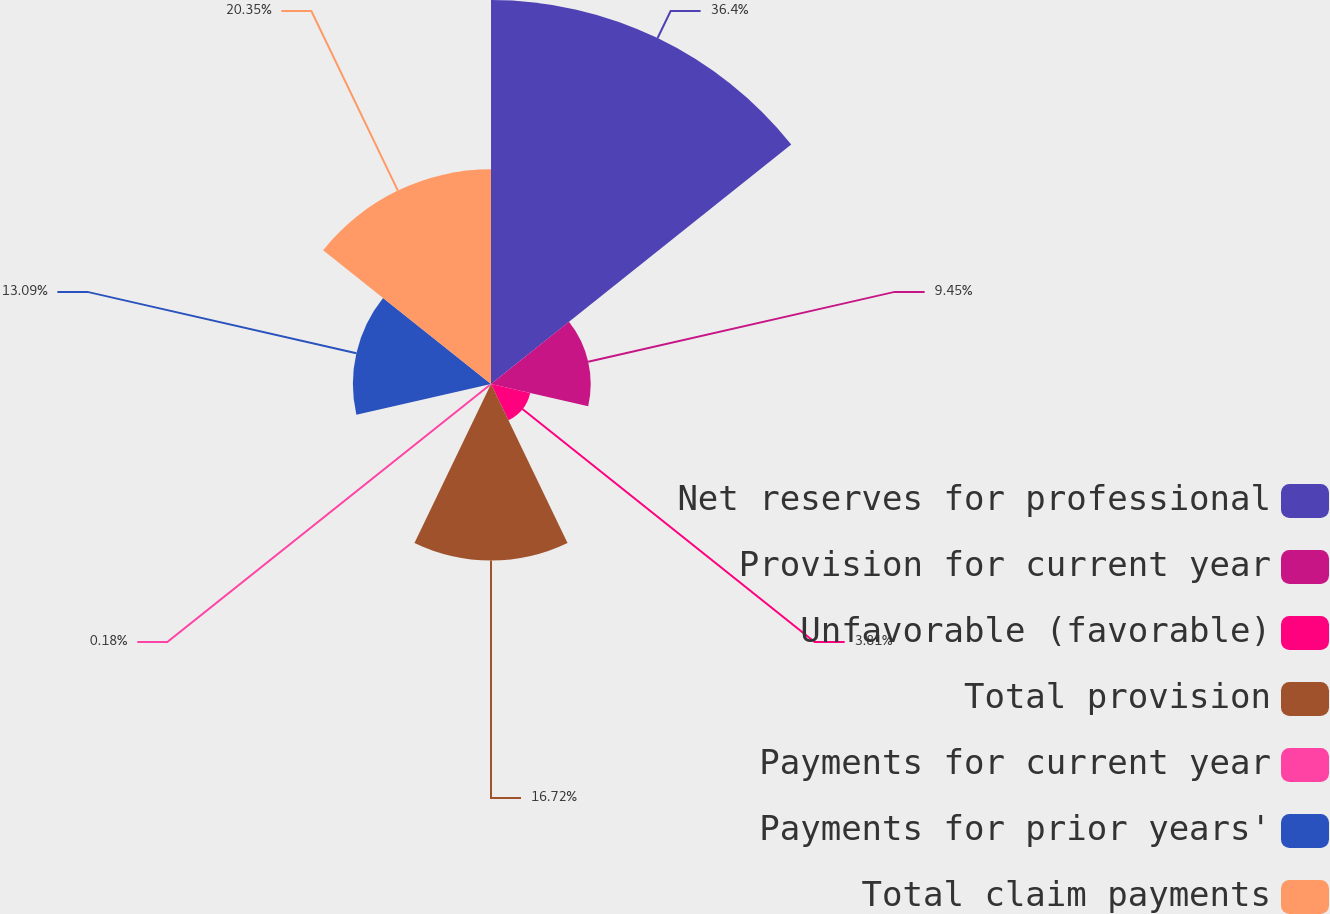Convert chart. <chart><loc_0><loc_0><loc_500><loc_500><pie_chart><fcel>Net reserves for professional<fcel>Provision for current year<fcel>Unfavorable (favorable)<fcel>Total provision<fcel>Payments for current year<fcel>Payments for prior years'<fcel>Total claim payments<nl><fcel>36.4%<fcel>9.45%<fcel>3.81%<fcel>16.72%<fcel>0.18%<fcel>13.09%<fcel>20.35%<nl></chart> 